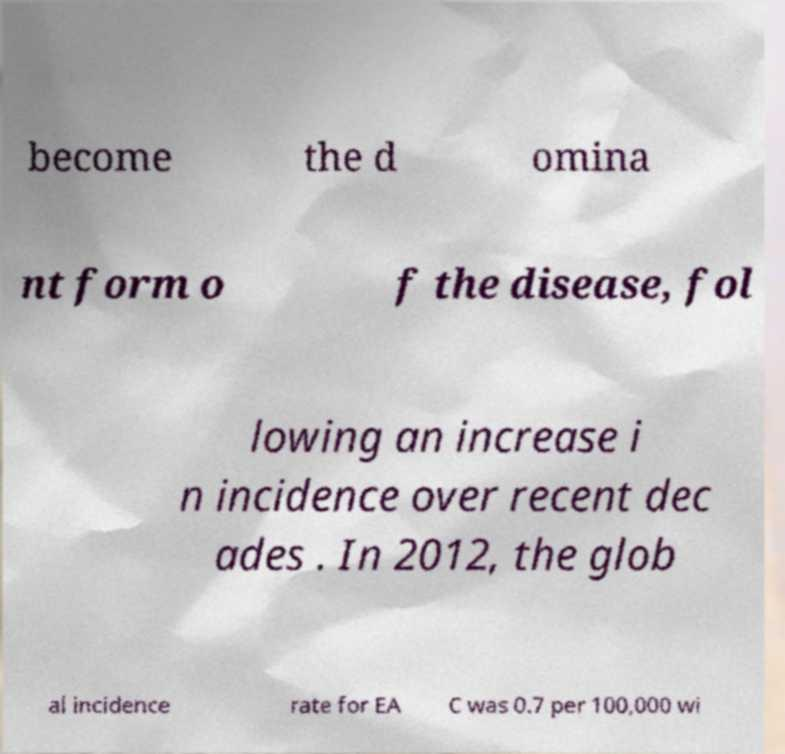Can you accurately transcribe the text from the provided image for me? become the d omina nt form o f the disease, fol lowing an increase i n incidence over recent dec ades . In 2012, the glob al incidence rate for EA C was 0.7 per 100,000 wi 